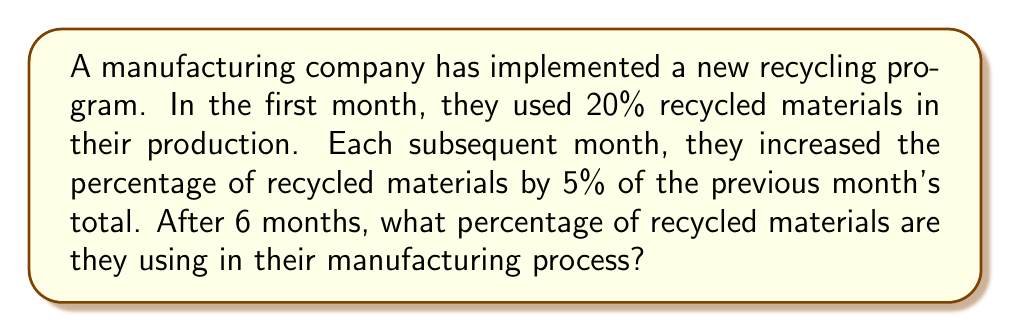What is the answer to this math problem? Let's approach this step-by-step:

1) Initial percentage: 20%

2) Monthly increase: 5% of the previous month's total

3) Let's calculate for each month:

   Month 1: 20%
   Month 2: $20\% + (5\% \times 20\%) = 20\% + 1\% = 21\%$
   Month 3: $21\% + (5\% \times 21\%) = 21\% + 1.05\% = 22.05\%$
   Month 4: $22.05\% + (5\% \times 22.05\%) = 22.05\% + 1.1025\% = 23.1525\%$
   Month 5: $23.1525\% + (5\% \times 23.1525\%) = 23.1525\% + 1.157625\% = 24.310125\%$
   Month 6: $24.310125\% + (5\% \times 24.310125\%) = 24.310125\% + 1.21550625\% = 25.52563125\%$

4) We can express this mathematically as:

   $$P_n = P_{n-1} + (0.05 \times P_{n-1}) = 1.05 \times P_{n-1}$$

   Where $P_n$ is the percentage in month n.

5) This forms a geometric sequence with first term $a = 20$ and common ratio $r = 1.05$

6) The 6th term of this sequence is given by:

   $$P_6 = 20 \times (1.05)^5 = 25.52563125\%$$
Answer: 25.53% (rounded to 2 decimal places) 